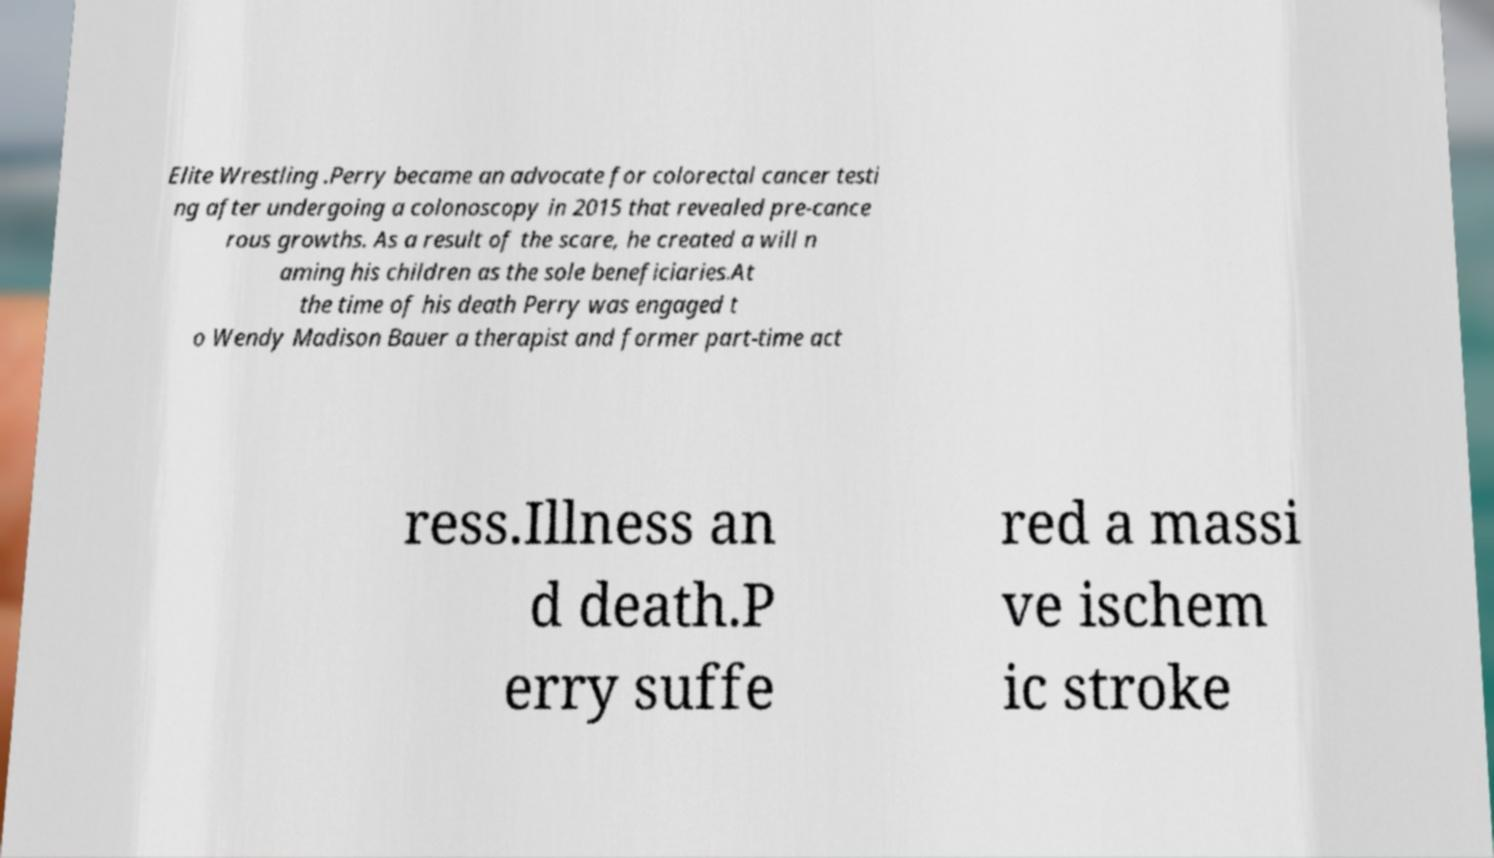For documentation purposes, I need the text within this image transcribed. Could you provide that? Elite Wrestling .Perry became an advocate for colorectal cancer testi ng after undergoing a colonoscopy in 2015 that revealed pre-cance rous growths. As a result of the scare, he created a will n aming his children as the sole beneficiaries.At the time of his death Perry was engaged t o Wendy Madison Bauer a therapist and former part-time act ress.Illness an d death.P erry suffe red a massi ve ischem ic stroke 